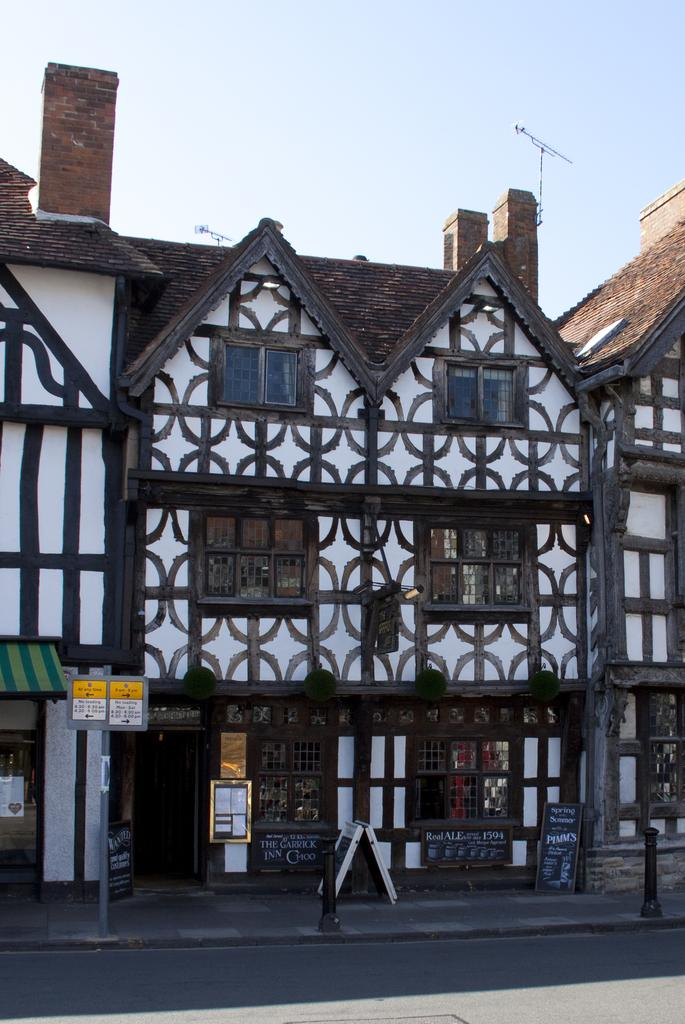What type of structure is present in the image? There is a building in the image. What other objects can be seen in the image? There is a pole, rods, windows, and boards visible in the image. Can you describe the background of the image? The sky is visible in the background of the image. What type of temper can be seen in the image? There is no temper present in the image; it is a still image of a building, pole, rods, windows, boards, and the sky. 